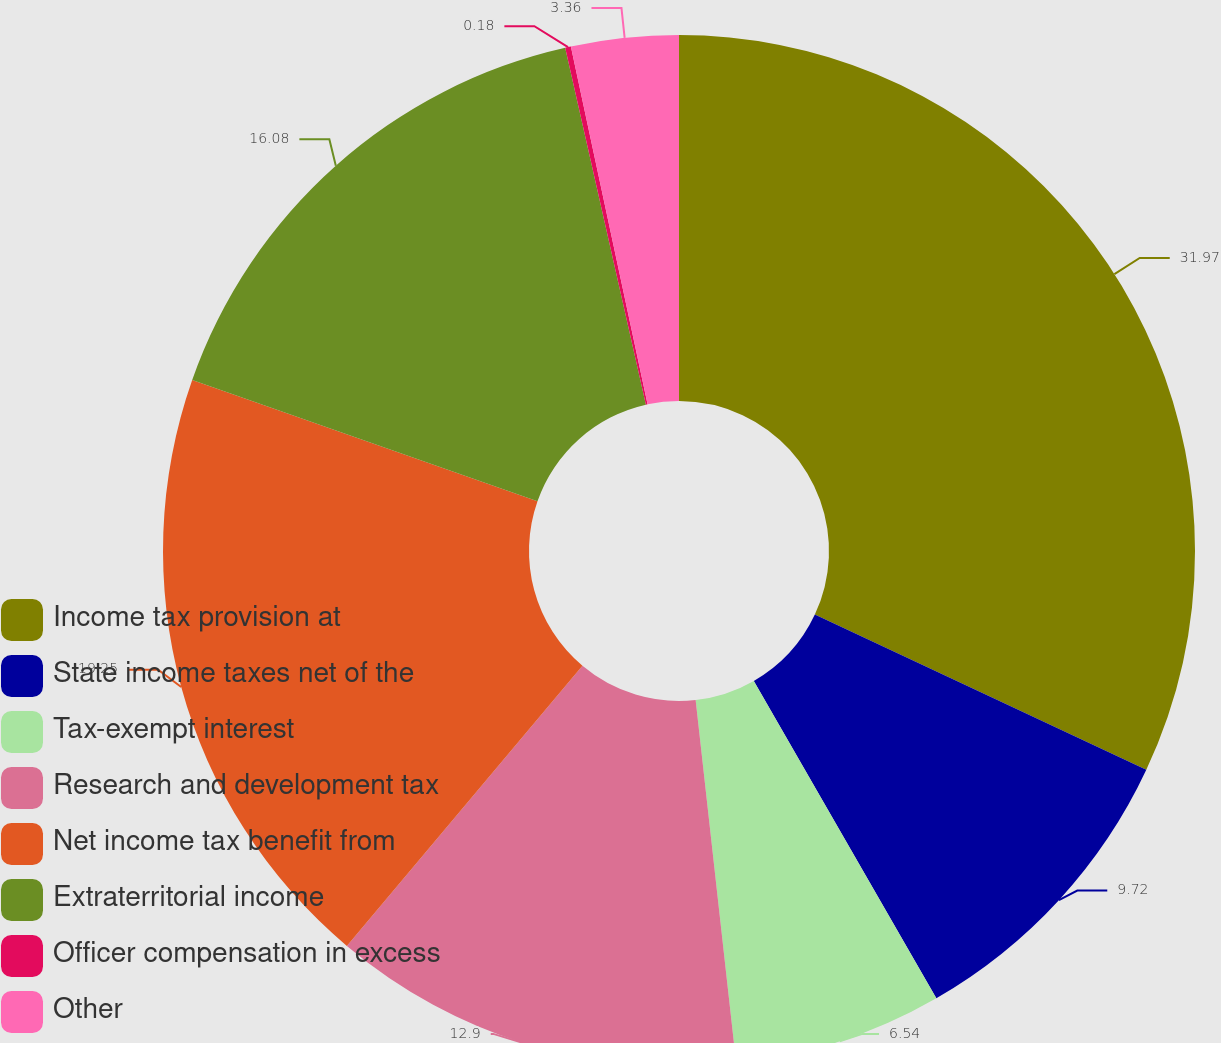Convert chart to OTSL. <chart><loc_0><loc_0><loc_500><loc_500><pie_chart><fcel>Income tax provision at<fcel>State income taxes net of the<fcel>Tax-exempt interest<fcel>Research and development tax<fcel>Net income tax benefit from<fcel>Extraterritorial income<fcel>Officer compensation in excess<fcel>Other<nl><fcel>31.97%<fcel>9.72%<fcel>6.54%<fcel>12.9%<fcel>19.25%<fcel>16.08%<fcel>0.18%<fcel>3.36%<nl></chart> 